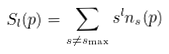<formula> <loc_0><loc_0><loc_500><loc_500>S _ { l } ( p ) = \sum _ { s \ne s _ { \max } } s ^ { l } n _ { s } ( p )</formula> 